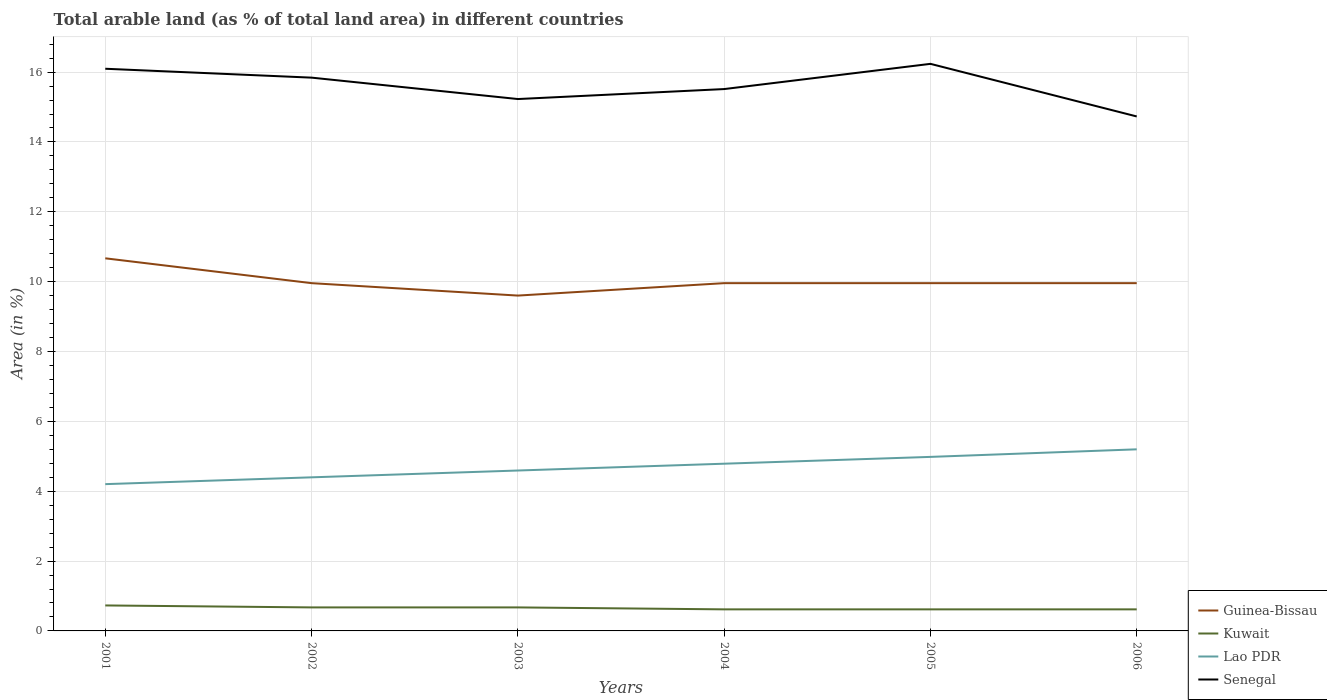How many different coloured lines are there?
Your answer should be very brief. 4. Does the line corresponding to Lao PDR intersect with the line corresponding to Guinea-Bissau?
Your answer should be compact. No. Across all years, what is the maximum percentage of arable land in Lao PDR?
Ensure brevity in your answer.  4.2. What is the total percentage of arable land in Guinea-Bissau in the graph?
Offer a terse response. 0.71. What is the difference between the highest and the second highest percentage of arable land in Guinea-Bissau?
Give a very brief answer. 1.07. How many lines are there?
Offer a terse response. 4. Does the graph contain any zero values?
Keep it short and to the point. No. Does the graph contain grids?
Keep it short and to the point. Yes. How many legend labels are there?
Offer a very short reply. 4. How are the legend labels stacked?
Make the answer very short. Vertical. What is the title of the graph?
Give a very brief answer. Total arable land (as % of total land area) in different countries. Does "Uganda" appear as one of the legend labels in the graph?
Provide a succinct answer. No. What is the label or title of the X-axis?
Ensure brevity in your answer.  Years. What is the label or title of the Y-axis?
Provide a short and direct response. Area (in %). What is the Area (in %) in Guinea-Bissau in 2001?
Provide a short and direct response. 10.67. What is the Area (in %) of Kuwait in 2001?
Give a very brief answer. 0.73. What is the Area (in %) in Lao PDR in 2001?
Provide a short and direct response. 4.2. What is the Area (in %) of Senegal in 2001?
Offer a terse response. 16.1. What is the Area (in %) in Guinea-Bissau in 2002?
Your answer should be very brief. 9.96. What is the Area (in %) in Kuwait in 2002?
Give a very brief answer. 0.67. What is the Area (in %) of Lao PDR in 2002?
Provide a short and direct response. 4.4. What is the Area (in %) of Senegal in 2002?
Provide a succinct answer. 15.84. What is the Area (in %) in Guinea-Bissau in 2003?
Your answer should be compact. 9.6. What is the Area (in %) of Kuwait in 2003?
Your answer should be compact. 0.67. What is the Area (in %) of Lao PDR in 2003?
Offer a terse response. 4.59. What is the Area (in %) of Senegal in 2003?
Keep it short and to the point. 15.23. What is the Area (in %) in Guinea-Bissau in 2004?
Make the answer very short. 9.96. What is the Area (in %) in Kuwait in 2004?
Your answer should be compact. 0.62. What is the Area (in %) of Lao PDR in 2004?
Your answer should be compact. 4.79. What is the Area (in %) of Senegal in 2004?
Provide a short and direct response. 15.51. What is the Area (in %) of Guinea-Bissau in 2005?
Keep it short and to the point. 9.96. What is the Area (in %) in Kuwait in 2005?
Give a very brief answer. 0.62. What is the Area (in %) of Lao PDR in 2005?
Ensure brevity in your answer.  4.98. What is the Area (in %) in Senegal in 2005?
Your response must be concise. 16.24. What is the Area (in %) in Guinea-Bissau in 2006?
Ensure brevity in your answer.  9.96. What is the Area (in %) in Kuwait in 2006?
Your answer should be compact. 0.62. What is the Area (in %) of Lao PDR in 2006?
Your response must be concise. 5.2. What is the Area (in %) of Senegal in 2006?
Give a very brief answer. 14.73. Across all years, what is the maximum Area (in %) in Guinea-Bissau?
Your response must be concise. 10.67. Across all years, what is the maximum Area (in %) of Kuwait?
Ensure brevity in your answer.  0.73. Across all years, what is the maximum Area (in %) of Lao PDR?
Provide a short and direct response. 5.2. Across all years, what is the maximum Area (in %) in Senegal?
Your answer should be compact. 16.24. Across all years, what is the minimum Area (in %) of Guinea-Bissau?
Offer a terse response. 9.6. Across all years, what is the minimum Area (in %) of Kuwait?
Provide a succinct answer. 0.62. Across all years, what is the minimum Area (in %) in Lao PDR?
Offer a terse response. 4.2. Across all years, what is the minimum Area (in %) in Senegal?
Your answer should be very brief. 14.73. What is the total Area (in %) in Guinea-Bissau in the graph?
Provide a succinct answer. 60.1. What is the total Area (in %) of Kuwait in the graph?
Offer a very short reply. 3.93. What is the total Area (in %) of Lao PDR in the graph?
Offer a very short reply. 28.16. What is the total Area (in %) of Senegal in the graph?
Make the answer very short. 93.65. What is the difference between the Area (in %) in Guinea-Bissau in 2001 and that in 2002?
Make the answer very short. 0.71. What is the difference between the Area (in %) of Kuwait in 2001 and that in 2002?
Provide a short and direct response. 0.06. What is the difference between the Area (in %) in Lao PDR in 2001 and that in 2002?
Offer a terse response. -0.2. What is the difference between the Area (in %) in Senegal in 2001 and that in 2002?
Offer a terse response. 0.25. What is the difference between the Area (in %) of Guinea-Bissau in 2001 and that in 2003?
Provide a short and direct response. 1.07. What is the difference between the Area (in %) of Kuwait in 2001 and that in 2003?
Offer a terse response. 0.06. What is the difference between the Area (in %) in Lao PDR in 2001 and that in 2003?
Your answer should be very brief. -0.39. What is the difference between the Area (in %) in Senegal in 2001 and that in 2003?
Provide a succinct answer. 0.87. What is the difference between the Area (in %) of Guinea-Bissau in 2001 and that in 2004?
Your answer should be compact. 0.71. What is the difference between the Area (in %) in Kuwait in 2001 and that in 2004?
Your answer should be very brief. 0.11. What is the difference between the Area (in %) in Lao PDR in 2001 and that in 2004?
Ensure brevity in your answer.  -0.58. What is the difference between the Area (in %) of Senegal in 2001 and that in 2004?
Ensure brevity in your answer.  0.58. What is the difference between the Area (in %) in Guinea-Bissau in 2001 and that in 2005?
Your answer should be compact. 0.71. What is the difference between the Area (in %) in Kuwait in 2001 and that in 2005?
Make the answer very short. 0.11. What is the difference between the Area (in %) in Lao PDR in 2001 and that in 2005?
Provide a short and direct response. -0.78. What is the difference between the Area (in %) of Senegal in 2001 and that in 2005?
Provide a short and direct response. -0.14. What is the difference between the Area (in %) of Guinea-Bissau in 2001 and that in 2006?
Offer a terse response. 0.71. What is the difference between the Area (in %) of Kuwait in 2001 and that in 2006?
Give a very brief answer. 0.11. What is the difference between the Area (in %) in Lao PDR in 2001 and that in 2006?
Provide a short and direct response. -1. What is the difference between the Area (in %) of Senegal in 2001 and that in 2006?
Make the answer very short. 1.37. What is the difference between the Area (in %) in Guinea-Bissau in 2002 and that in 2003?
Your answer should be very brief. 0.36. What is the difference between the Area (in %) of Kuwait in 2002 and that in 2003?
Keep it short and to the point. 0. What is the difference between the Area (in %) of Lao PDR in 2002 and that in 2003?
Give a very brief answer. -0.2. What is the difference between the Area (in %) in Senegal in 2002 and that in 2003?
Offer a terse response. 0.61. What is the difference between the Area (in %) of Kuwait in 2002 and that in 2004?
Give a very brief answer. 0.06. What is the difference between the Area (in %) of Lao PDR in 2002 and that in 2004?
Your answer should be compact. -0.39. What is the difference between the Area (in %) of Senegal in 2002 and that in 2004?
Keep it short and to the point. 0.33. What is the difference between the Area (in %) in Kuwait in 2002 and that in 2005?
Make the answer very short. 0.06. What is the difference between the Area (in %) of Lao PDR in 2002 and that in 2005?
Your response must be concise. -0.58. What is the difference between the Area (in %) in Senegal in 2002 and that in 2005?
Keep it short and to the point. -0.39. What is the difference between the Area (in %) of Guinea-Bissau in 2002 and that in 2006?
Your answer should be very brief. 0. What is the difference between the Area (in %) of Kuwait in 2002 and that in 2006?
Ensure brevity in your answer.  0.06. What is the difference between the Area (in %) in Lao PDR in 2002 and that in 2006?
Make the answer very short. -0.8. What is the difference between the Area (in %) of Senegal in 2002 and that in 2006?
Your response must be concise. 1.11. What is the difference between the Area (in %) of Guinea-Bissau in 2003 and that in 2004?
Offer a very short reply. -0.36. What is the difference between the Area (in %) of Kuwait in 2003 and that in 2004?
Your response must be concise. 0.06. What is the difference between the Area (in %) in Lao PDR in 2003 and that in 2004?
Provide a succinct answer. -0.2. What is the difference between the Area (in %) in Senegal in 2003 and that in 2004?
Offer a terse response. -0.29. What is the difference between the Area (in %) of Guinea-Bissau in 2003 and that in 2005?
Provide a short and direct response. -0.36. What is the difference between the Area (in %) of Kuwait in 2003 and that in 2005?
Ensure brevity in your answer.  0.06. What is the difference between the Area (in %) of Lao PDR in 2003 and that in 2005?
Offer a very short reply. -0.39. What is the difference between the Area (in %) in Senegal in 2003 and that in 2005?
Your response must be concise. -1.01. What is the difference between the Area (in %) in Guinea-Bissau in 2003 and that in 2006?
Provide a short and direct response. -0.36. What is the difference between the Area (in %) in Kuwait in 2003 and that in 2006?
Your answer should be compact. 0.06. What is the difference between the Area (in %) of Lao PDR in 2003 and that in 2006?
Your answer should be compact. -0.61. What is the difference between the Area (in %) of Senegal in 2003 and that in 2006?
Provide a short and direct response. 0.5. What is the difference between the Area (in %) in Guinea-Bissau in 2004 and that in 2005?
Offer a very short reply. 0. What is the difference between the Area (in %) in Kuwait in 2004 and that in 2005?
Ensure brevity in your answer.  0. What is the difference between the Area (in %) of Lao PDR in 2004 and that in 2005?
Make the answer very short. -0.2. What is the difference between the Area (in %) in Senegal in 2004 and that in 2005?
Make the answer very short. -0.72. What is the difference between the Area (in %) in Lao PDR in 2004 and that in 2006?
Offer a very short reply. -0.41. What is the difference between the Area (in %) of Senegal in 2004 and that in 2006?
Ensure brevity in your answer.  0.78. What is the difference between the Area (in %) in Guinea-Bissau in 2005 and that in 2006?
Keep it short and to the point. 0. What is the difference between the Area (in %) of Lao PDR in 2005 and that in 2006?
Offer a very short reply. -0.22. What is the difference between the Area (in %) in Senegal in 2005 and that in 2006?
Your answer should be compact. 1.51. What is the difference between the Area (in %) in Guinea-Bissau in 2001 and the Area (in %) in Kuwait in 2002?
Offer a very short reply. 10. What is the difference between the Area (in %) in Guinea-Bissau in 2001 and the Area (in %) in Lao PDR in 2002?
Offer a terse response. 6.27. What is the difference between the Area (in %) of Guinea-Bissau in 2001 and the Area (in %) of Senegal in 2002?
Give a very brief answer. -5.17. What is the difference between the Area (in %) of Kuwait in 2001 and the Area (in %) of Lao PDR in 2002?
Provide a succinct answer. -3.67. What is the difference between the Area (in %) of Kuwait in 2001 and the Area (in %) of Senegal in 2002?
Make the answer very short. -15.11. What is the difference between the Area (in %) in Lao PDR in 2001 and the Area (in %) in Senegal in 2002?
Your answer should be compact. -11.64. What is the difference between the Area (in %) of Guinea-Bissau in 2001 and the Area (in %) of Kuwait in 2003?
Your answer should be very brief. 10. What is the difference between the Area (in %) of Guinea-Bissau in 2001 and the Area (in %) of Lao PDR in 2003?
Make the answer very short. 6.08. What is the difference between the Area (in %) in Guinea-Bissau in 2001 and the Area (in %) in Senegal in 2003?
Provide a short and direct response. -4.56. What is the difference between the Area (in %) of Kuwait in 2001 and the Area (in %) of Lao PDR in 2003?
Offer a very short reply. -3.86. What is the difference between the Area (in %) of Kuwait in 2001 and the Area (in %) of Senegal in 2003?
Ensure brevity in your answer.  -14.5. What is the difference between the Area (in %) in Lao PDR in 2001 and the Area (in %) in Senegal in 2003?
Ensure brevity in your answer.  -11.03. What is the difference between the Area (in %) in Guinea-Bissau in 2001 and the Area (in %) in Kuwait in 2004?
Your response must be concise. 10.05. What is the difference between the Area (in %) in Guinea-Bissau in 2001 and the Area (in %) in Lao PDR in 2004?
Your answer should be very brief. 5.88. What is the difference between the Area (in %) of Guinea-Bissau in 2001 and the Area (in %) of Senegal in 2004?
Offer a very short reply. -4.85. What is the difference between the Area (in %) of Kuwait in 2001 and the Area (in %) of Lao PDR in 2004?
Give a very brief answer. -4.06. What is the difference between the Area (in %) in Kuwait in 2001 and the Area (in %) in Senegal in 2004?
Provide a short and direct response. -14.78. What is the difference between the Area (in %) in Lao PDR in 2001 and the Area (in %) in Senegal in 2004?
Ensure brevity in your answer.  -11.31. What is the difference between the Area (in %) in Guinea-Bissau in 2001 and the Area (in %) in Kuwait in 2005?
Ensure brevity in your answer.  10.05. What is the difference between the Area (in %) of Guinea-Bissau in 2001 and the Area (in %) of Lao PDR in 2005?
Your response must be concise. 5.69. What is the difference between the Area (in %) of Guinea-Bissau in 2001 and the Area (in %) of Senegal in 2005?
Keep it short and to the point. -5.57. What is the difference between the Area (in %) in Kuwait in 2001 and the Area (in %) in Lao PDR in 2005?
Offer a terse response. -4.25. What is the difference between the Area (in %) of Kuwait in 2001 and the Area (in %) of Senegal in 2005?
Your answer should be very brief. -15.51. What is the difference between the Area (in %) of Lao PDR in 2001 and the Area (in %) of Senegal in 2005?
Make the answer very short. -12.03. What is the difference between the Area (in %) of Guinea-Bissau in 2001 and the Area (in %) of Kuwait in 2006?
Give a very brief answer. 10.05. What is the difference between the Area (in %) in Guinea-Bissau in 2001 and the Area (in %) in Lao PDR in 2006?
Your answer should be very brief. 5.47. What is the difference between the Area (in %) of Guinea-Bissau in 2001 and the Area (in %) of Senegal in 2006?
Your response must be concise. -4.06. What is the difference between the Area (in %) in Kuwait in 2001 and the Area (in %) in Lao PDR in 2006?
Keep it short and to the point. -4.47. What is the difference between the Area (in %) of Kuwait in 2001 and the Area (in %) of Senegal in 2006?
Your response must be concise. -14. What is the difference between the Area (in %) of Lao PDR in 2001 and the Area (in %) of Senegal in 2006?
Provide a succinct answer. -10.53. What is the difference between the Area (in %) of Guinea-Bissau in 2002 and the Area (in %) of Kuwait in 2003?
Offer a very short reply. 9.28. What is the difference between the Area (in %) of Guinea-Bissau in 2002 and the Area (in %) of Lao PDR in 2003?
Offer a very short reply. 5.36. What is the difference between the Area (in %) of Guinea-Bissau in 2002 and the Area (in %) of Senegal in 2003?
Keep it short and to the point. -5.27. What is the difference between the Area (in %) of Kuwait in 2002 and the Area (in %) of Lao PDR in 2003?
Your answer should be compact. -3.92. What is the difference between the Area (in %) in Kuwait in 2002 and the Area (in %) in Senegal in 2003?
Ensure brevity in your answer.  -14.56. What is the difference between the Area (in %) of Lao PDR in 2002 and the Area (in %) of Senegal in 2003?
Make the answer very short. -10.83. What is the difference between the Area (in %) of Guinea-Bissau in 2002 and the Area (in %) of Kuwait in 2004?
Ensure brevity in your answer.  9.34. What is the difference between the Area (in %) of Guinea-Bissau in 2002 and the Area (in %) of Lao PDR in 2004?
Ensure brevity in your answer.  5.17. What is the difference between the Area (in %) in Guinea-Bissau in 2002 and the Area (in %) in Senegal in 2004?
Make the answer very short. -5.56. What is the difference between the Area (in %) in Kuwait in 2002 and the Area (in %) in Lao PDR in 2004?
Give a very brief answer. -4.11. What is the difference between the Area (in %) in Kuwait in 2002 and the Area (in %) in Senegal in 2004?
Make the answer very short. -14.84. What is the difference between the Area (in %) in Lao PDR in 2002 and the Area (in %) in Senegal in 2004?
Your answer should be compact. -11.12. What is the difference between the Area (in %) in Guinea-Bissau in 2002 and the Area (in %) in Kuwait in 2005?
Offer a terse response. 9.34. What is the difference between the Area (in %) of Guinea-Bissau in 2002 and the Area (in %) of Lao PDR in 2005?
Provide a short and direct response. 4.97. What is the difference between the Area (in %) of Guinea-Bissau in 2002 and the Area (in %) of Senegal in 2005?
Make the answer very short. -6.28. What is the difference between the Area (in %) of Kuwait in 2002 and the Area (in %) of Lao PDR in 2005?
Provide a short and direct response. -4.31. What is the difference between the Area (in %) of Kuwait in 2002 and the Area (in %) of Senegal in 2005?
Provide a succinct answer. -15.56. What is the difference between the Area (in %) of Lao PDR in 2002 and the Area (in %) of Senegal in 2005?
Your response must be concise. -11.84. What is the difference between the Area (in %) in Guinea-Bissau in 2002 and the Area (in %) in Kuwait in 2006?
Your answer should be compact. 9.34. What is the difference between the Area (in %) in Guinea-Bissau in 2002 and the Area (in %) in Lao PDR in 2006?
Keep it short and to the point. 4.76. What is the difference between the Area (in %) in Guinea-Bissau in 2002 and the Area (in %) in Senegal in 2006?
Your answer should be very brief. -4.77. What is the difference between the Area (in %) in Kuwait in 2002 and the Area (in %) in Lao PDR in 2006?
Make the answer very short. -4.53. What is the difference between the Area (in %) of Kuwait in 2002 and the Area (in %) of Senegal in 2006?
Offer a terse response. -14.06. What is the difference between the Area (in %) in Lao PDR in 2002 and the Area (in %) in Senegal in 2006?
Provide a succinct answer. -10.33. What is the difference between the Area (in %) in Guinea-Bissau in 2003 and the Area (in %) in Kuwait in 2004?
Provide a short and direct response. 8.98. What is the difference between the Area (in %) of Guinea-Bissau in 2003 and the Area (in %) of Lao PDR in 2004?
Provide a short and direct response. 4.81. What is the difference between the Area (in %) in Guinea-Bissau in 2003 and the Area (in %) in Senegal in 2004?
Make the answer very short. -5.91. What is the difference between the Area (in %) in Kuwait in 2003 and the Area (in %) in Lao PDR in 2004?
Your answer should be very brief. -4.11. What is the difference between the Area (in %) in Kuwait in 2003 and the Area (in %) in Senegal in 2004?
Offer a terse response. -14.84. What is the difference between the Area (in %) of Lao PDR in 2003 and the Area (in %) of Senegal in 2004?
Provide a succinct answer. -10.92. What is the difference between the Area (in %) of Guinea-Bissau in 2003 and the Area (in %) of Kuwait in 2005?
Provide a short and direct response. 8.98. What is the difference between the Area (in %) of Guinea-Bissau in 2003 and the Area (in %) of Lao PDR in 2005?
Your answer should be very brief. 4.62. What is the difference between the Area (in %) of Guinea-Bissau in 2003 and the Area (in %) of Senegal in 2005?
Give a very brief answer. -6.63. What is the difference between the Area (in %) in Kuwait in 2003 and the Area (in %) in Lao PDR in 2005?
Offer a terse response. -4.31. What is the difference between the Area (in %) of Kuwait in 2003 and the Area (in %) of Senegal in 2005?
Make the answer very short. -15.56. What is the difference between the Area (in %) of Lao PDR in 2003 and the Area (in %) of Senegal in 2005?
Ensure brevity in your answer.  -11.64. What is the difference between the Area (in %) of Guinea-Bissau in 2003 and the Area (in %) of Kuwait in 2006?
Offer a very short reply. 8.98. What is the difference between the Area (in %) of Guinea-Bissau in 2003 and the Area (in %) of Lao PDR in 2006?
Keep it short and to the point. 4.4. What is the difference between the Area (in %) of Guinea-Bissau in 2003 and the Area (in %) of Senegal in 2006?
Ensure brevity in your answer.  -5.13. What is the difference between the Area (in %) in Kuwait in 2003 and the Area (in %) in Lao PDR in 2006?
Make the answer very short. -4.53. What is the difference between the Area (in %) of Kuwait in 2003 and the Area (in %) of Senegal in 2006?
Your response must be concise. -14.06. What is the difference between the Area (in %) in Lao PDR in 2003 and the Area (in %) in Senegal in 2006?
Ensure brevity in your answer.  -10.14. What is the difference between the Area (in %) of Guinea-Bissau in 2004 and the Area (in %) of Kuwait in 2005?
Make the answer very short. 9.34. What is the difference between the Area (in %) of Guinea-Bissau in 2004 and the Area (in %) of Lao PDR in 2005?
Make the answer very short. 4.97. What is the difference between the Area (in %) in Guinea-Bissau in 2004 and the Area (in %) in Senegal in 2005?
Ensure brevity in your answer.  -6.28. What is the difference between the Area (in %) in Kuwait in 2004 and the Area (in %) in Lao PDR in 2005?
Your response must be concise. -4.37. What is the difference between the Area (in %) of Kuwait in 2004 and the Area (in %) of Senegal in 2005?
Offer a very short reply. -15.62. What is the difference between the Area (in %) in Lao PDR in 2004 and the Area (in %) in Senegal in 2005?
Give a very brief answer. -11.45. What is the difference between the Area (in %) of Guinea-Bissau in 2004 and the Area (in %) of Kuwait in 2006?
Provide a short and direct response. 9.34. What is the difference between the Area (in %) of Guinea-Bissau in 2004 and the Area (in %) of Lao PDR in 2006?
Provide a short and direct response. 4.76. What is the difference between the Area (in %) of Guinea-Bissau in 2004 and the Area (in %) of Senegal in 2006?
Your response must be concise. -4.77. What is the difference between the Area (in %) in Kuwait in 2004 and the Area (in %) in Lao PDR in 2006?
Provide a succinct answer. -4.58. What is the difference between the Area (in %) in Kuwait in 2004 and the Area (in %) in Senegal in 2006?
Give a very brief answer. -14.11. What is the difference between the Area (in %) of Lao PDR in 2004 and the Area (in %) of Senegal in 2006?
Your response must be concise. -9.94. What is the difference between the Area (in %) in Guinea-Bissau in 2005 and the Area (in %) in Kuwait in 2006?
Provide a succinct answer. 9.34. What is the difference between the Area (in %) of Guinea-Bissau in 2005 and the Area (in %) of Lao PDR in 2006?
Provide a short and direct response. 4.76. What is the difference between the Area (in %) of Guinea-Bissau in 2005 and the Area (in %) of Senegal in 2006?
Offer a terse response. -4.77. What is the difference between the Area (in %) in Kuwait in 2005 and the Area (in %) in Lao PDR in 2006?
Your response must be concise. -4.58. What is the difference between the Area (in %) in Kuwait in 2005 and the Area (in %) in Senegal in 2006?
Make the answer very short. -14.11. What is the difference between the Area (in %) in Lao PDR in 2005 and the Area (in %) in Senegal in 2006?
Offer a very short reply. -9.75. What is the average Area (in %) in Guinea-Bissau per year?
Offer a very short reply. 10.02. What is the average Area (in %) of Kuwait per year?
Give a very brief answer. 0.65. What is the average Area (in %) in Lao PDR per year?
Offer a very short reply. 4.69. What is the average Area (in %) of Senegal per year?
Ensure brevity in your answer.  15.61. In the year 2001, what is the difference between the Area (in %) in Guinea-Bissau and Area (in %) in Kuwait?
Make the answer very short. 9.94. In the year 2001, what is the difference between the Area (in %) of Guinea-Bissau and Area (in %) of Lao PDR?
Keep it short and to the point. 6.47. In the year 2001, what is the difference between the Area (in %) of Guinea-Bissau and Area (in %) of Senegal?
Keep it short and to the point. -5.43. In the year 2001, what is the difference between the Area (in %) in Kuwait and Area (in %) in Lao PDR?
Provide a succinct answer. -3.47. In the year 2001, what is the difference between the Area (in %) of Kuwait and Area (in %) of Senegal?
Offer a very short reply. -15.37. In the year 2001, what is the difference between the Area (in %) in Lao PDR and Area (in %) in Senegal?
Ensure brevity in your answer.  -11.89. In the year 2002, what is the difference between the Area (in %) of Guinea-Bissau and Area (in %) of Kuwait?
Your answer should be very brief. 9.28. In the year 2002, what is the difference between the Area (in %) of Guinea-Bissau and Area (in %) of Lao PDR?
Offer a terse response. 5.56. In the year 2002, what is the difference between the Area (in %) in Guinea-Bissau and Area (in %) in Senegal?
Your answer should be very brief. -5.88. In the year 2002, what is the difference between the Area (in %) of Kuwait and Area (in %) of Lao PDR?
Your answer should be compact. -3.72. In the year 2002, what is the difference between the Area (in %) of Kuwait and Area (in %) of Senegal?
Provide a short and direct response. -15.17. In the year 2002, what is the difference between the Area (in %) of Lao PDR and Area (in %) of Senegal?
Your answer should be very brief. -11.44. In the year 2003, what is the difference between the Area (in %) in Guinea-Bissau and Area (in %) in Kuwait?
Offer a terse response. 8.93. In the year 2003, what is the difference between the Area (in %) in Guinea-Bissau and Area (in %) in Lao PDR?
Keep it short and to the point. 5.01. In the year 2003, what is the difference between the Area (in %) in Guinea-Bissau and Area (in %) in Senegal?
Offer a terse response. -5.63. In the year 2003, what is the difference between the Area (in %) in Kuwait and Area (in %) in Lao PDR?
Give a very brief answer. -3.92. In the year 2003, what is the difference between the Area (in %) of Kuwait and Area (in %) of Senegal?
Ensure brevity in your answer.  -14.56. In the year 2003, what is the difference between the Area (in %) of Lao PDR and Area (in %) of Senegal?
Your answer should be compact. -10.64. In the year 2004, what is the difference between the Area (in %) in Guinea-Bissau and Area (in %) in Kuwait?
Your answer should be compact. 9.34. In the year 2004, what is the difference between the Area (in %) in Guinea-Bissau and Area (in %) in Lao PDR?
Your response must be concise. 5.17. In the year 2004, what is the difference between the Area (in %) in Guinea-Bissau and Area (in %) in Senegal?
Your response must be concise. -5.56. In the year 2004, what is the difference between the Area (in %) of Kuwait and Area (in %) of Lao PDR?
Make the answer very short. -4.17. In the year 2004, what is the difference between the Area (in %) in Kuwait and Area (in %) in Senegal?
Keep it short and to the point. -14.9. In the year 2004, what is the difference between the Area (in %) of Lao PDR and Area (in %) of Senegal?
Ensure brevity in your answer.  -10.73. In the year 2005, what is the difference between the Area (in %) in Guinea-Bissau and Area (in %) in Kuwait?
Give a very brief answer. 9.34. In the year 2005, what is the difference between the Area (in %) in Guinea-Bissau and Area (in %) in Lao PDR?
Your answer should be very brief. 4.97. In the year 2005, what is the difference between the Area (in %) of Guinea-Bissau and Area (in %) of Senegal?
Provide a short and direct response. -6.28. In the year 2005, what is the difference between the Area (in %) in Kuwait and Area (in %) in Lao PDR?
Ensure brevity in your answer.  -4.37. In the year 2005, what is the difference between the Area (in %) of Kuwait and Area (in %) of Senegal?
Offer a very short reply. -15.62. In the year 2005, what is the difference between the Area (in %) in Lao PDR and Area (in %) in Senegal?
Ensure brevity in your answer.  -11.25. In the year 2006, what is the difference between the Area (in %) of Guinea-Bissau and Area (in %) of Kuwait?
Offer a very short reply. 9.34. In the year 2006, what is the difference between the Area (in %) in Guinea-Bissau and Area (in %) in Lao PDR?
Ensure brevity in your answer.  4.76. In the year 2006, what is the difference between the Area (in %) in Guinea-Bissau and Area (in %) in Senegal?
Provide a succinct answer. -4.77. In the year 2006, what is the difference between the Area (in %) in Kuwait and Area (in %) in Lao PDR?
Offer a very short reply. -4.58. In the year 2006, what is the difference between the Area (in %) of Kuwait and Area (in %) of Senegal?
Your response must be concise. -14.11. In the year 2006, what is the difference between the Area (in %) of Lao PDR and Area (in %) of Senegal?
Give a very brief answer. -9.53. What is the ratio of the Area (in %) of Guinea-Bissau in 2001 to that in 2002?
Offer a terse response. 1.07. What is the ratio of the Area (in %) in Kuwait in 2001 to that in 2002?
Provide a succinct answer. 1.08. What is the ratio of the Area (in %) of Lao PDR in 2001 to that in 2002?
Your answer should be compact. 0.96. What is the ratio of the Area (in %) in Senegal in 2001 to that in 2002?
Your answer should be very brief. 1.02. What is the ratio of the Area (in %) of Kuwait in 2001 to that in 2003?
Offer a terse response. 1.08. What is the ratio of the Area (in %) of Lao PDR in 2001 to that in 2003?
Keep it short and to the point. 0.92. What is the ratio of the Area (in %) in Senegal in 2001 to that in 2003?
Provide a short and direct response. 1.06. What is the ratio of the Area (in %) in Guinea-Bissau in 2001 to that in 2004?
Make the answer very short. 1.07. What is the ratio of the Area (in %) in Kuwait in 2001 to that in 2004?
Your answer should be very brief. 1.18. What is the ratio of the Area (in %) of Lao PDR in 2001 to that in 2004?
Provide a succinct answer. 0.88. What is the ratio of the Area (in %) in Senegal in 2001 to that in 2004?
Ensure brevity in your answer.  1.04. What is the ratio of the Area (in %) in Guinea-Bissau in 2001 to that in 2005?
Give a very brief answer. 1.07. What is the ratio of the Area (in %) of Kuwait in 2001 to that in 2005?
Offer a very short reply. 1.18. What is the ratio of the Area (in %) of Lao PDR in 2001 to that in 2005?
Give a very brief answer. 0.84. What is the ratio of the Area (in %) in Guinea-Bissau in 2001 to that in 2006?
Offer a very short reply. 1.07. What is the ratio of the Area (in %) in Kuwait in 2001 to that in 2006?
Ensure brevity in your answer.  1.18. What is the ratio of the Area (in %) in Lao PDR in 2001 to that in 2006?
Your response must be concise. 0.81. What is the ratio of the Area (in %) in Senegal in 2001 to that in 2006?
Your answer should be very brief. 1.09. What is the ratio of the Area (in %) of Guinea-Bissau in 2002 to that in 2003?
Offer a terse response. 1.04. What is the ratio of the Area (in %) in Lao PDR in 2002 to that in 2003?
Your response must be concise. 0.96. What is the ratio of the Area (in %) of Senegal in 2002 to that in 2003?
Your answer should be compact. 1.04. What is the ratio of the Area (in %) of Lao PDR in 2002 to that in 2004?
Provide a short and direct response. 0.92. What is the ratio of the Area (in %) in Senegal in 2002 to that in 2004?
Offer a very short reply. 1.02. What is the ratio of the Area (in %) of Kuwait in 2002 to that in 2005?
Provide a short and direct response. 1.09. What is the ratio of the Area (in %) of Lao PDR in 2002 to that in 2005?
Provide a short and direct response. 0.88. What is the ratio of the Area (in %) in Senegal in 2002 to that in 2005?
Your answer should be very brief. 0.98. What is the ratio of the Area (in %) in Guinea-Bissau in 2002 to that in 2006?
Your answer should be very brief. 1. What is the ratio of the Area (in %) of Lao PDR in 2002 to that in 2006?
Provide a succinct answer. 0.85. What is the ratio of the Area (in %) of Senegal in 2002 to that in 2006?
Provide a short and direct response. 1.08. What is the ratio of the Area (in %) of Guinea-Bissau in 2003 to that in 2004?
Keep it short and to the point. 0.96. What is the ratio of the Area (in %) in Lao PDR in 2003 to that in 2004?
Your answer should be very brief. 0.96. What is the ratio of the Area (in %) in Senegal in 2003 to that in 2004?
Keep it short and to the point. 0.98. What is the ratio of the Area (in %) of Kuwait in 2003 to that in 2005?
Give a very brief answer. 1.09. What is the ratio of the Area (in %) of Lao PDR in 2003 to that in 2005?
Offer a terse response. 0.92. What is the ratio of the Area (in %) of Senegal in 2003 to that in 2005?
Your answer should be very brief. 0.94. What is the ratio of the Area (in %) in Guinea-Bissau in 2003 to that in 2006?
Make the answer very short. 0.96. What is the ratio of the Area (in %) in Lao PDR in 2003 to that in 2006?
Offer a very short reply. 0.88. What is the ratio of the Area (in %) of Senegal in 2003 to that in 2006?
Provide a short and direct response. 1.03. What is the ratio of the Area (in %) of Guinea-Bissau in 2004 to that in 2005?
Offer a terse response. 1. What is the ratio of the Area (in %) of Lao PDR in 2004 to that in 2005?
Your answer should be compact. 0.96. What is the ratio of the Area (in %) of Senegal in 2004 to that in 2005?
Your answer should be very brief. 0.96. What is the ratio of the Area (in %) of Lao PDR in 2004 to that in 2006?
Make the answer very short. 0.92. What is the ratio of the Area (in %) of Senegal in 2004 to that in 2006?
Give a very brief answer. 1.05. What is the ratio of the Area (in %) of Lao PDR in 2005 to that in 2006?
Keep it short and to the point. 0.96. What is the ratio of the Area (in %) in Senegal in 2005 to that in 2006?
Keep it short and to the point. 1.1. What is the difference between the highest and the second highest Area (in %) in Guinea-Bissau?
Your answer should be compact. 0.71. What is the difference between the highest and the second highest Area (in %) of Kuwait?
Your answer should be compact. 0.06. What is the difference between the highest and the second highest Area (in %) in Lao PDR?
Give a very brief answer. 0.22. What is the difference between the highest and the second highest Area (in %) in Senegal?
Provide a succinct answer. 0.14. What is the difference between the highest and the lowest Area (in %) in Guinea-Bissau?
Your response must be concise. 1.07. What is the difference between the highest and the lowest Area (in %) in Kuwait?
Make the answer very short. 0.11. What is the difference between the highest and the lowest Area (in %) in Senegal?
Make the answer very short. 1.51. 